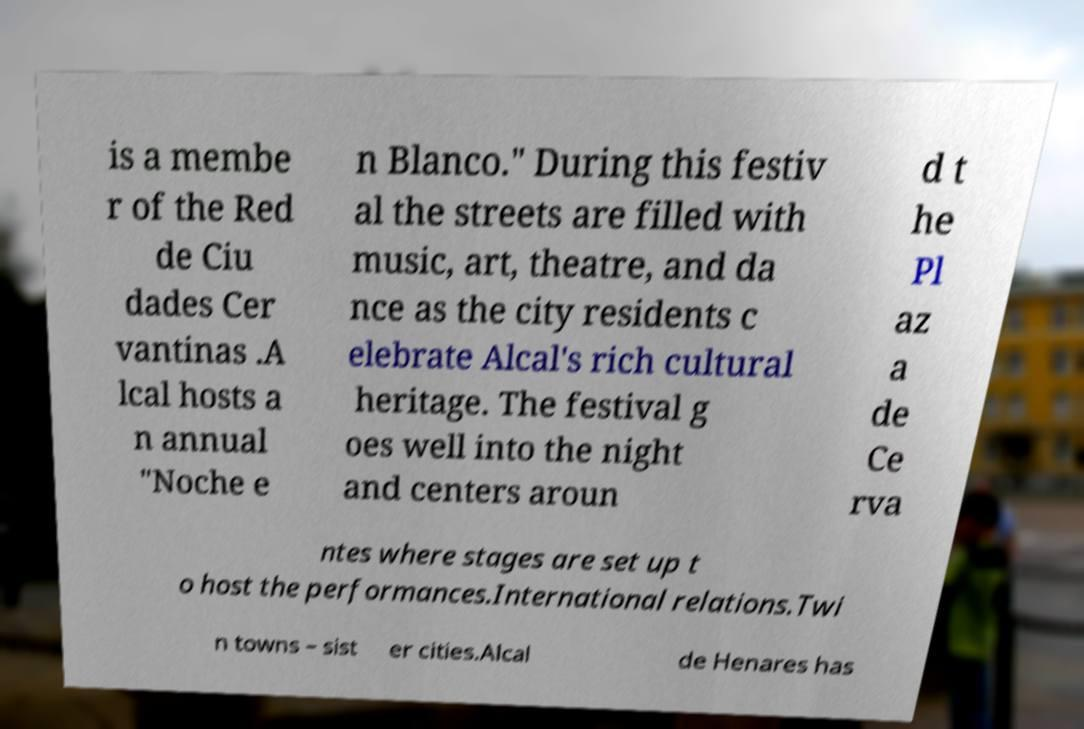Can you accurately transcribe the text from the provided image for me? is a membe r of the Red de Ciu dades Cer vantinas .A lcal hosts a n annual "Noche e n Blanco." During this festiv al the streets are filled with music, art, theatre, and da nce as the city residents c elebrate Alcal's rich cultural heritage. The festival g oes well into the night and centers aroun d t he Pl az a de Ce rva ntes where stages are set up t o host the performances.International relations.Twi n towns – sist er cities.Alcal de Henares has 